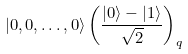<formula> <loc_0><loc_0><loc_500><loc_500>| 0 , 0 , \dots , 0 \rangle \left ( \frac { | 0 \rangle - | 1 \rangle } { \sqrt { 2 } } \right ) _ { q }</formula> 